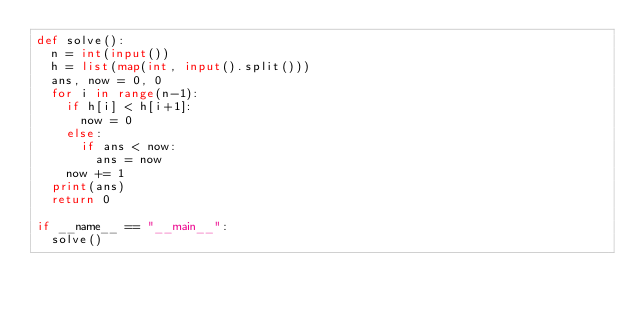Convert code to text. <code><loc_0><loc_0><loc_500><loc_500><_Python_>def solve():
  n = int(input())
  h = list(map(int, input().split()))
  ans, now = 0, 0
  for i in range(n-1):
    if h[i] < h[i+1]:
      now = 0
    else:
      if ans < now:
        ans = now
    now += 1
  print(ans)
  return 0
 
if __name__ == "__main__":
  solve()
</code> 